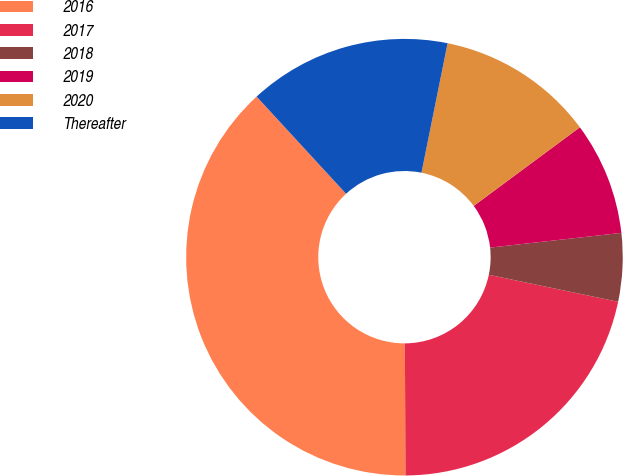Convert chart to OTSL. <chart><loc_0><loc_0><loc_500><loc_500><pie_chart><fcel>2016<fcel>2017<fcel>2018<fcel>2019<fcel>2020<fcel>Thereafter<nl><fcel>38.24%<fcel>21.65%<fcel>5.05%<fcel>8.37%<fcel>11.69%<fcel>15.01%<nl></chart> 